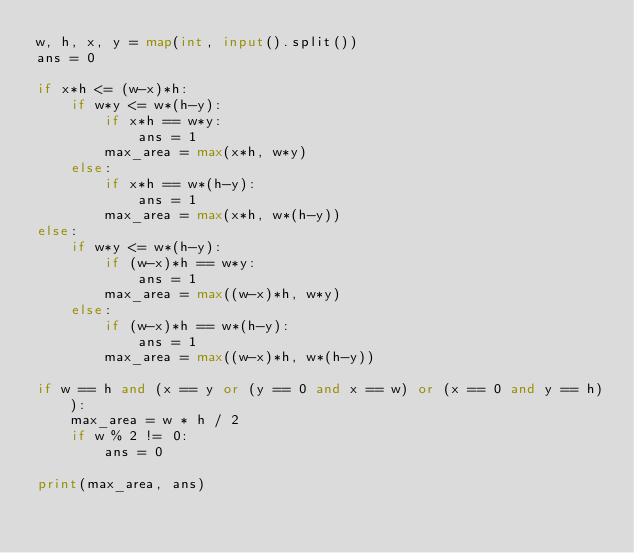Convert code to text. <code><loc_0><loc_0><loc_500><loc_500><_Python_>w, h, x, y = map(int, input().split())
ans = 0

if x*h <= (w-x)*h:
    if w*y <= w*(h-y):
        if x*h == w*y:
            ans = 1
        max_area = max(x*h, w*y)
    else:
        if x*h == w*(h-y):
            ans = 1
        max_area = max(x*h, w*(h-y))
else:
    if w*y <= w*(h-y):
        if (w-x)*h == w*y:
            ans = 1
        max_area = max((w-x)*h, w*y)
    else:
        if (w-x)*h == w*(h-y):
            ans = 1
        max_area = max((w-x)*h, w*(h-y))

if w == h and (x == y or (y == 0 and x == w) or (x == 0 and y == h)):
    max_area = w * h / 2
    if w % 2 != 0:
        ans = 0

print(max_area, ans)</code> 